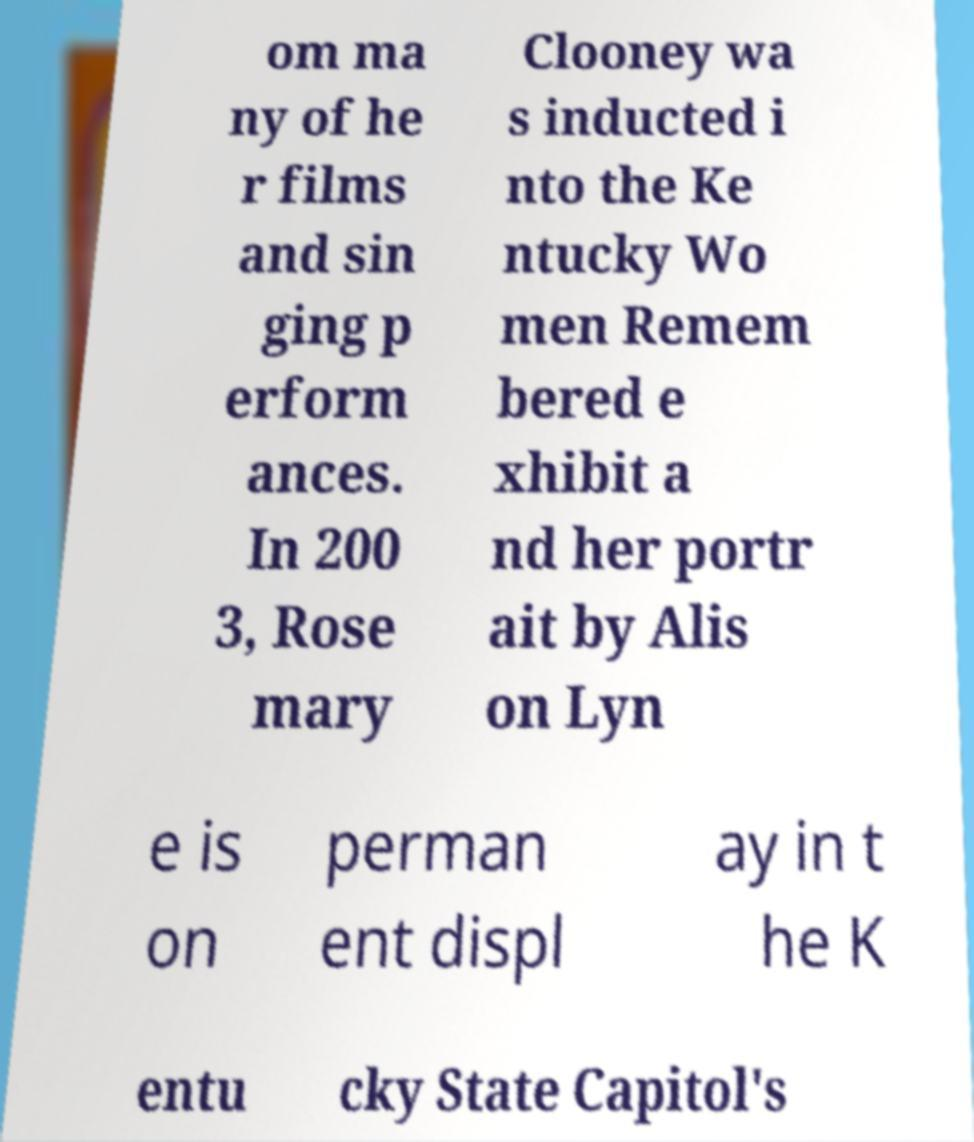There's text embedded in this image that I need extracted. Can you transcribe it verbatim? om ma ny of he r films and sin ging p erform ances. In 200 3, Rose mary Clooney wa s inducted i nto the Ke ntucky Wo men Remem bered e xhibit a nd her portr ait by Alis on Lyn e is on perman ent displ ay in t he K entu cky State Capitol's 